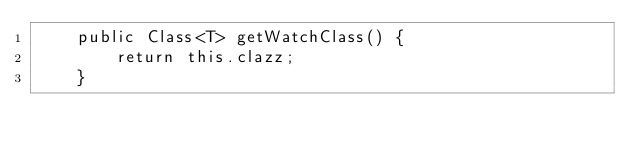Convert code to text. <code><loc_0><loc_0><loc_500><loc_500><_Java_>	public Class<T> getWatchClass() {
		return this.clazz;
	}
	</code> 